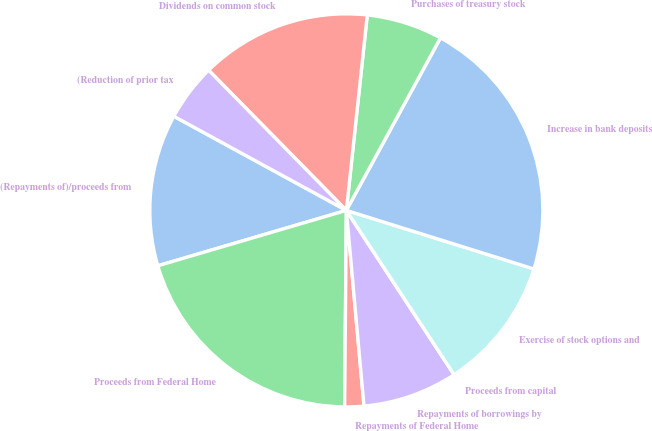Convert chart to OTSL. <chart><loc_0><loc_0><loc_500><loc_500><pie_chart><fcel>(Repayments of)/proceeds from<fcel>Proceeds from Federal Home<fcel>Repayments of Federal Home<fcel>Repayments of borrowings by<fcel>Proceeds from capital<fcel>Exercise of stock options and<fcel>Increase in bank deposits<fcel>Purchases of treasury stock<fcel>Dividends on common stock<fcel>(Reduction of prior tax<nl><fcel>12.5%<fcel>20.31%<fcel>1.57%<fcel>7.81%<fcel>0.0%<fcel>10.94%<fcel>21.87%<fcel>6.25%<fcel>14.06%<fcel>4.69%<nl></chart> 